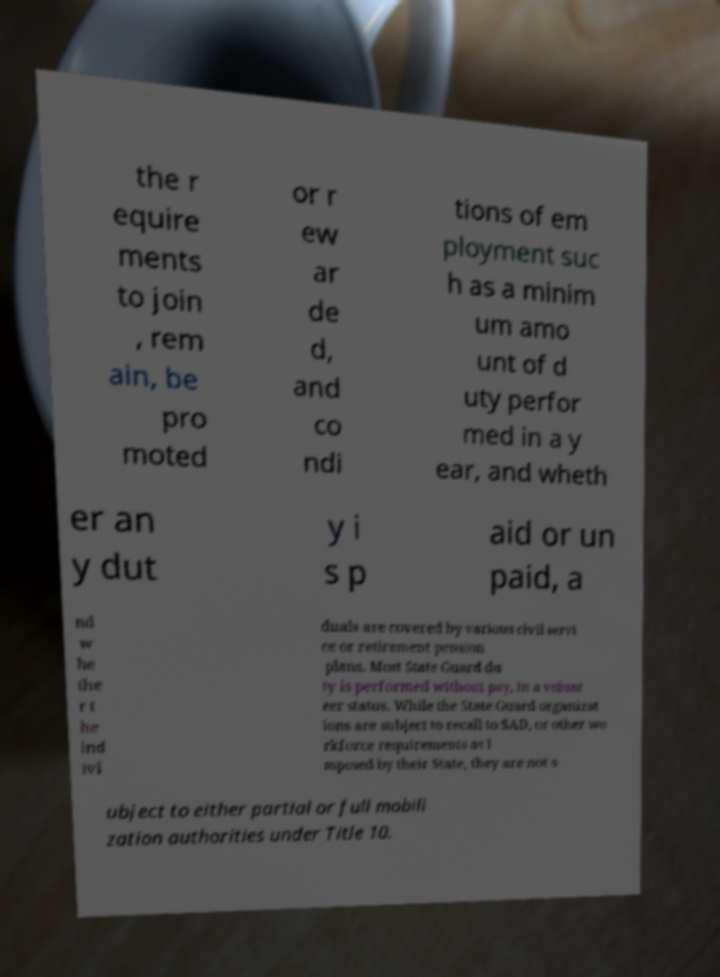Please identify and transcribe the text found in this image. the r equire ments to join , rem ain, be pro moted or r ew ar de d, and co ndi tions of em ployment suc h as a minim um amo unt of d uty perfor med in a y ear, and wheth er an y dut y i s p aid or un paid, a nd w he the r t he ind ivi duals are covered by various civil servi ce or retirement pension plans. Most State Guard du ty is performed without pay, in a volunt eer status. While the State Guard organizat ions are subject to recall to SAD, or other wo rkforce requirements as i mposed by their State, they are not s ubject to either partial or full mobili zation authorities under Title 10. 